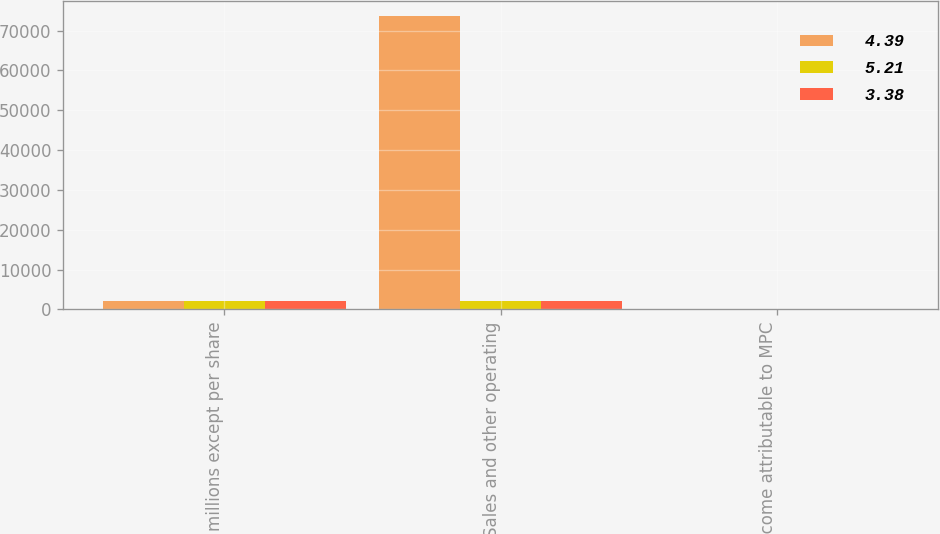<chart> <loc_0><loc_0><loc_500><loc_500><stacked_bar_chart><ecel><fcel>(In millions except per share<fcel>Sales and other operating<fcel>Net income attributable to MPC<nl><fcel>4.39<fcel>2015<fcel>73760<fcel>5.21<nl><fcel>5.21<fcel>2014<fcel>2013<fcel>4.39<nl><fcel>3.38<fcel>2013<fcel>2013<fcel>3.38<nl></chart> 